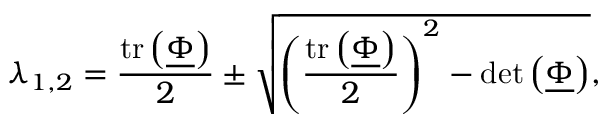Convert formula to latex. <formula><loc_0><loc_0><loc_500><loc_500>\lambda _ { 1 , 2 } = \frac { t r \left ( \underline { \Phi } \right ) } { 2 } \pm \sqrt { \left ( \frac { t r \left ( \underline { \Phi } \right ) } { 2 } \right ) ^ { 2 } - d e t \left ( \underline { \Phi } \right ) } ,</formula> 